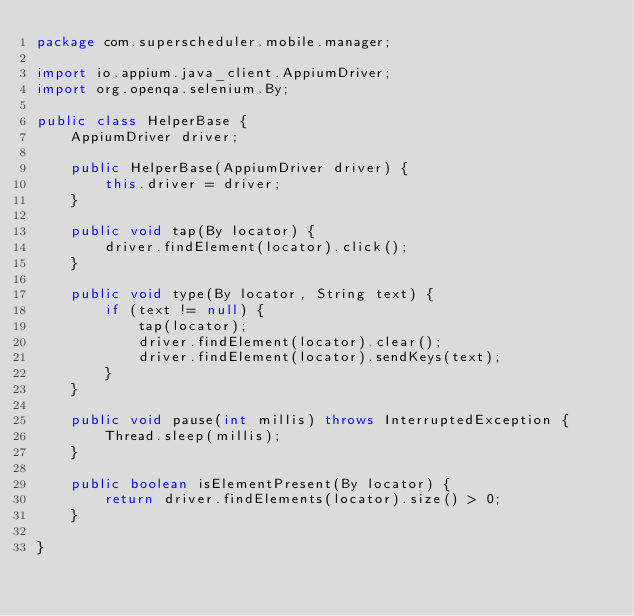<code> <loc_0><loc_0><loc_500><loc_500><_Java_>package com.superscheduler.mobile.manager;

import io.appium.java_client.AppiumDriver;
import org.openqa.selenium.By;

public class HelperBase {
    AppiumDriver driver;

    public HelperBase(AppiumDriver driver) {
        this.driver = driver;
    }

    public void tap(By locator) {
        driver.findElement(locator).click();
    }

    public void type(By locator, String text) {
        if (text != null) {
            tap(locator);
            driver.findElement(locator).clear();
            driver.findElement(locator).sendKeys(text);
        }
    }

    public void pause(int millis) throws InterruptedException {
        Thread.sleep(millis);
    }

    public boolean isElementPresent(By locator) {
        return driver.findElements(locator).size() > 0;
    }

}</code> 